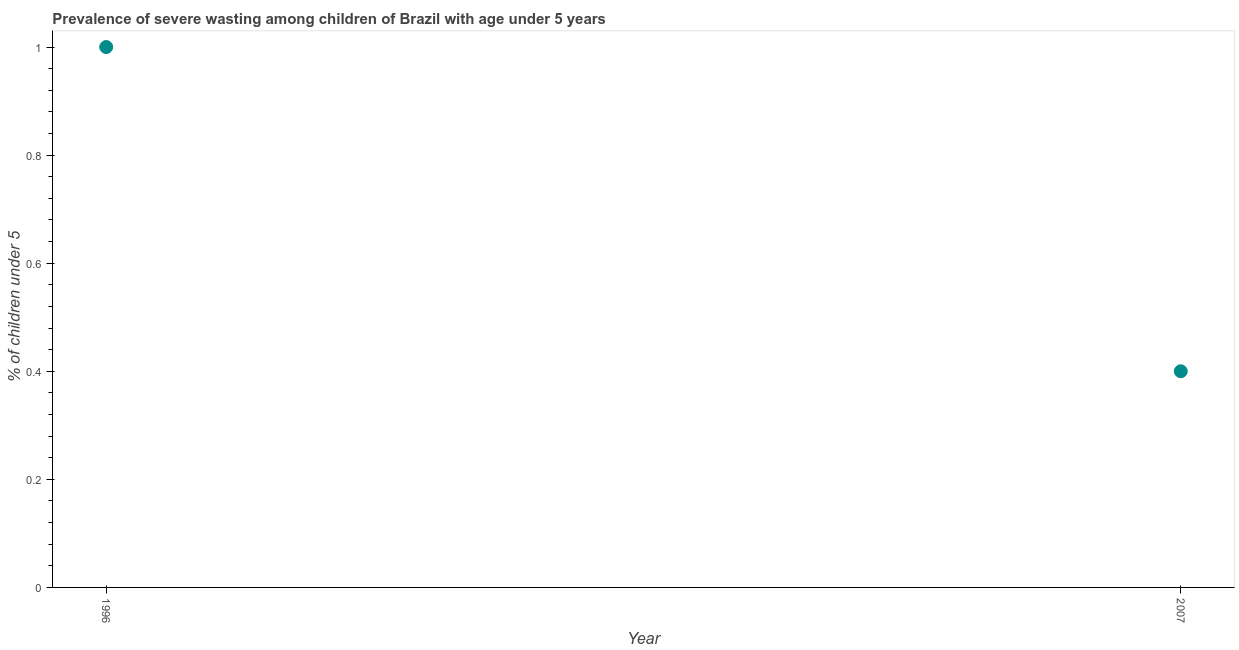What is the prevalence of severe wasting in 2007?
Provide a succinct answer. 0.4. Across all years, what is the minimum prevalence of severe wasting?
Provide a succinct answer. 0.4. In which year was the prevalence of severe wasting maximum?
Ensure brevity in your answer.  1996. What is the sum of the prevalence of severe wasting?
Your response must be concise. 1.4. What is the difference between the prevalence of severe wasting in 1996 and 2007?
Provide a short and direct response. 0.6. What is the average prevalence of severe wasting per year?
Your response must be concise. 0.7. What is the median prevalence of severe wasting?
Provide a short and direct response. 0.7. In how many years, is the prevalence of severe wasting greater than 0.2 %?
Your answer should be compact. 2. Do a majority of the years between 1996 and 2007 (inclusive) have prevalence of severe wasting greater than 0.32 %?
Your answer should be very brief. Yes. What is the ratio of the prevalence of severe wasting in 1996 to that in 2007?
Your response must be concise. 2.5. In how many years, is the prevalence of severe wasting greater than the average prevalence of severe wasting taken over all years?
Keep it short and to the point. 1. Does the prevalence of severe wasting monotonically increase over the years?
Provide a short and direct response. No. How many dotlines are there?
Provide a succinct answer. 1. Are the values on the major ticks of Y-axis written in scientific E-notation?
Your response must be concise. No. Does the graph contain any zero values?
Ensure brevity in your answer.  No. What is the title of the graph?
Provide a succinct answer. Prevalence of severe wasting among children of Brazil with age under 5 years. What is the label or title of the Y-axis?
Offer a very short reply.  % of children under 5. What is the  % of children under 5 in 2007?
Offer a very short reply. 0.4. What is the difference between the  % of children under 5 in 1996 and 2007?
Your response must be concise. 0.6. What is the ratio of the  % of children under 5 in 1996 to that in 2007?
Keep it short and to the point. 2.5. 